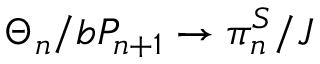Convert formula to latex. <formula><loc_0><loc_0><loc_500><loc_500>\Theta _ { n } / b P _ { n + 1 } \to \pi _ { n } ^ { S } / J</formula> 